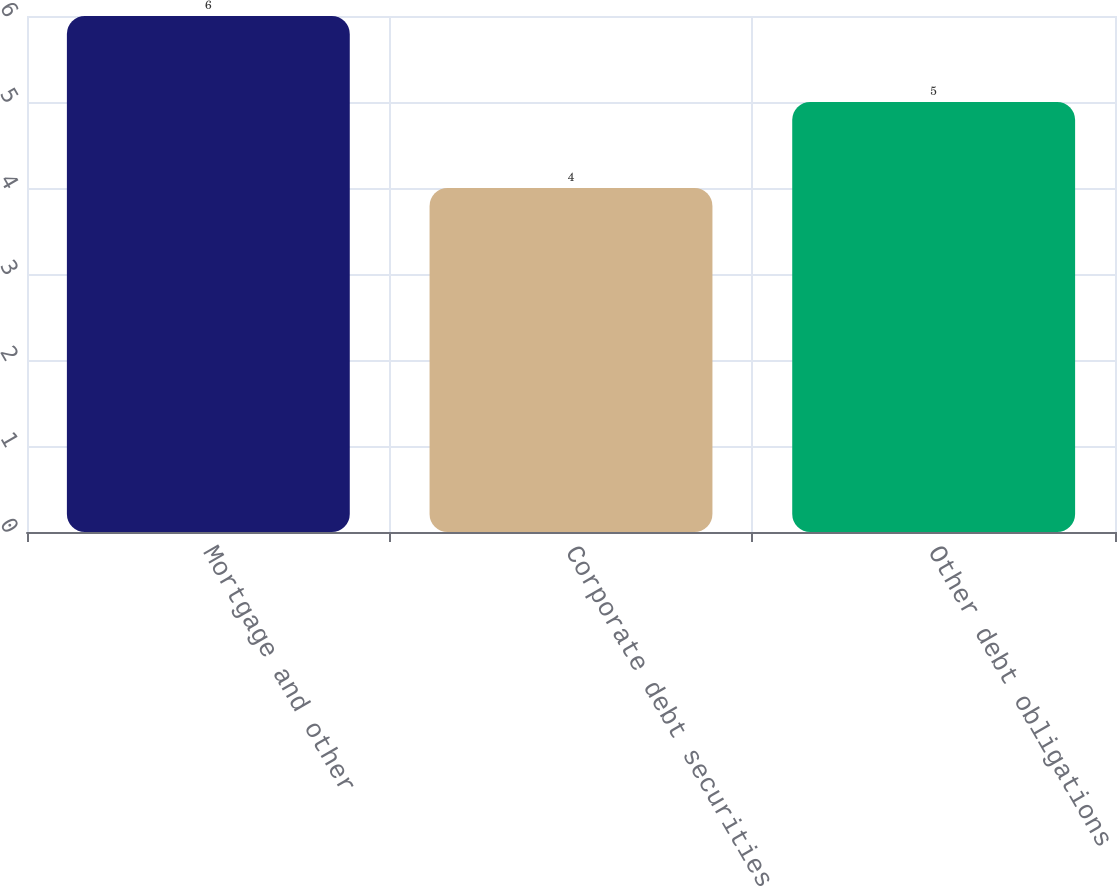Convert chart. <chart><loc_0><loc_0><loc_500><loc_500><bar_chart><fcel>Mortgage and other<fcel>Corporate debt securities<fcel>Other debt obligations<nl><fcel>6<fcel>4<fcel>5<nl></chart> 